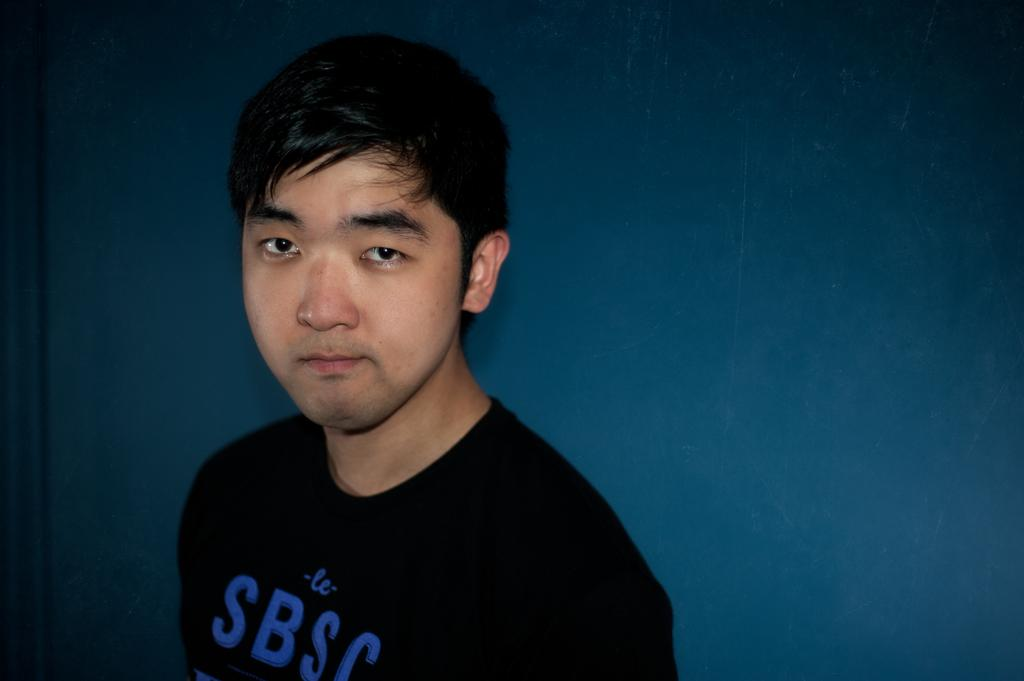What is the main subject of the image? There is a person in the image. What is the person wearing in the image? The person is wearing a black t-shirt. What color is the background of the image? The background of the image is blue in color. What type of lettuce can be seen growing in the background of the image? There is no lettuce present in the image; the background is blue in color. 